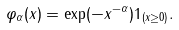Convert formula to latex. <formula><loc_0><loc_0><loc_500><loc_500>\varphi _ { \alpha } ( x ) = \exp ( - x ^ { - \alpha } ) 1 _ { ( x \geq 0 ) } .</formula> 